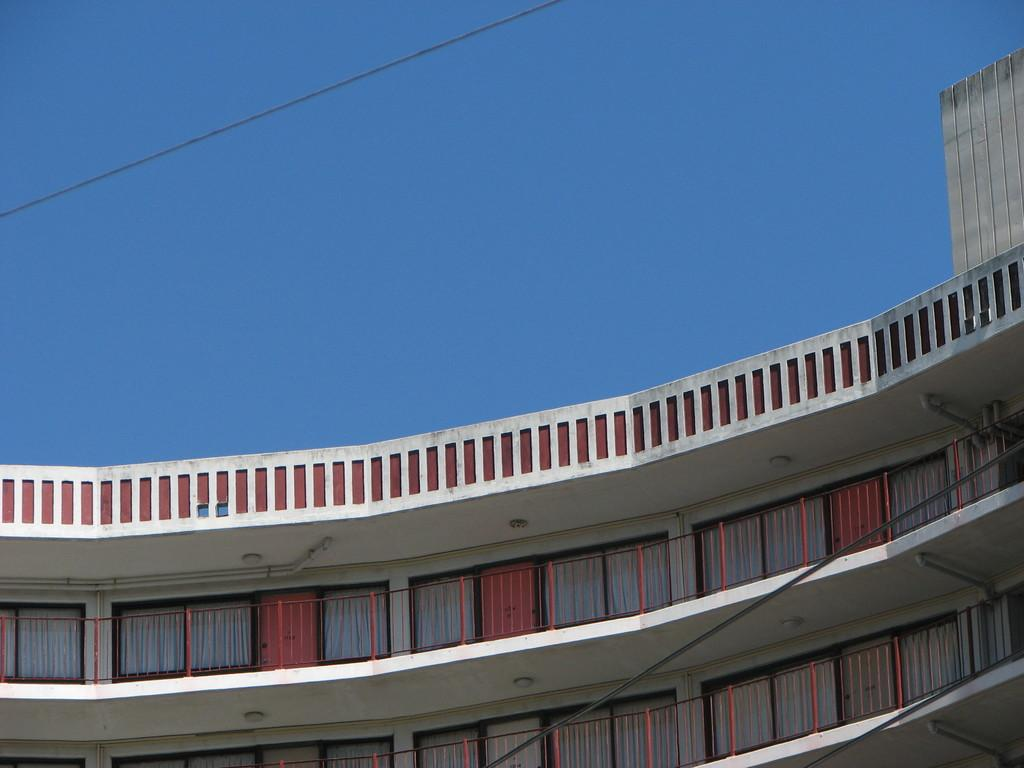What type of structure is shown in the image? The image is of a building. What architectural features can be seen on the building? The building has many windows and doors. How many floors of the building are visible in the image? Only two floors of the building are visible in the image. What can be seen in the background of the image? The sky is visible in the background of the image. What type of copper patch can be seen on the building's roof in the image? There is no copper patch visible on the building's roof in the image. What route does the building follow in the image? The image is a still photograph and does not depict a route or movement. 